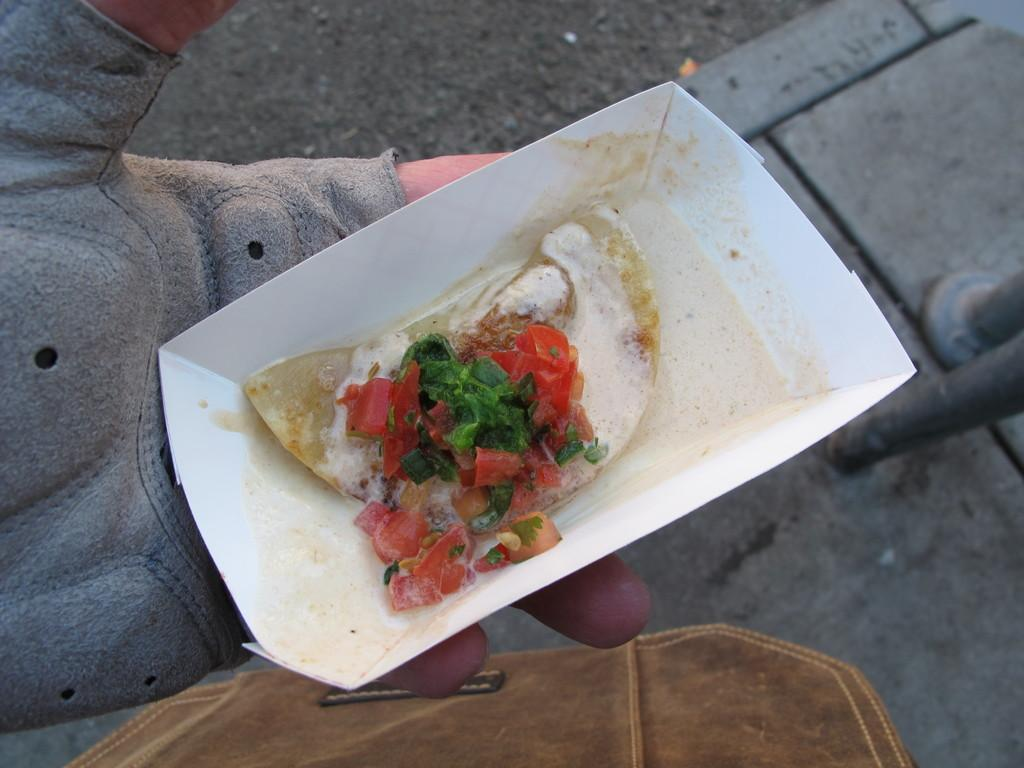Who or what is the main subject in the image? There is a person in the image. What is the person holding in the image? The person is holding a plate of food. Can you describe the person's hand in the image? The person's hand is visible in the image, and they are wearing a glove. What else can be seen in the foreground of the image? There is a bag in the foreground of the image. What type of notebook is the person using to write on the sidewalk in the image? There is no notebook or sidewalk present in the image; it features a person holding a plate of food and wearing a glove. 